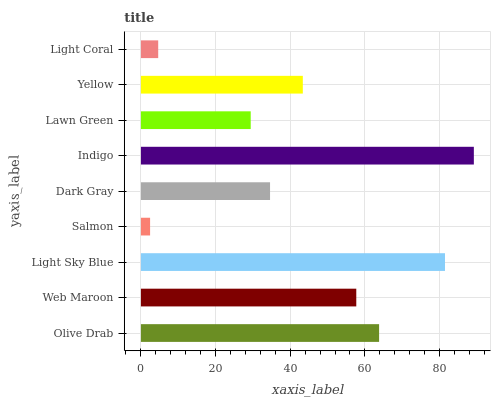Is Salmon the minimum?
Answer yes or no. Yes. Is Indigo the maximum?
Answer yes or no. Yes. Is Web Maroon the minimum?
Answer yes or no. No. Is Web Maroon the maximum?
Answer yes or no. No. Is Olive Drab greater than Web Maroon?
Answer yes or no. Yes. Is Web Maroon less than Olive Drab?
Answer yes or no. Yes. Is Web Maroon greater than Olive Drab?
Answer yes or no. No. Is Olive Drab less than Web Maroon?
Answer yes or no. No. Is Yellow the high median?
Answer yes or no. Yes. Is Yellow the low median?
Answer yes or no. Yes. Is Light Coral the high median?
Answer yes or no. No. Is Light Coral the low median?
Answer yes or no. No. 